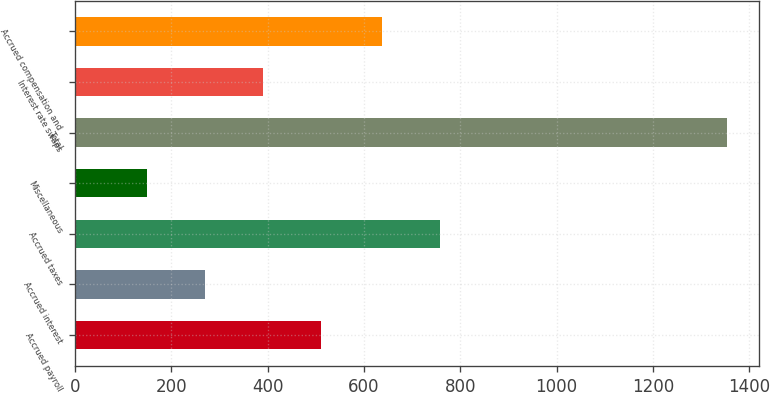Convert chart. <chart><loc_0><loc_0><loc_500><loc_500><bar_chart><fcel>Accrued payroll<fcel>Accrued interest<fcel>Accrued taxes<fcel>Miscellaneous<fcel>Total<fcel>Interest rate swaps<fcel>Accrued compensation and<nl><fcel>510.9<fcel>270.3<fcel>758.3<fcel>150<fcel>1353<fcel>390.6<fcel>638<nl></chart> 